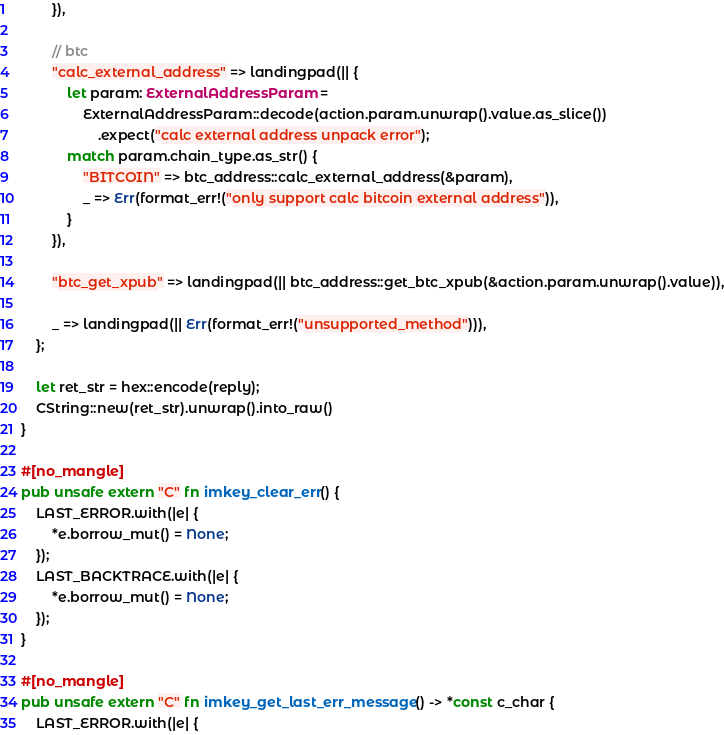Convert code to text. <code><loc_0><loc_0><loc_500><loc_500><_Rust_>        }),

        // btc
        "calc_external_address" => landingpad(|| {
            let param: ExternalAddressParam =
                ExternalAddressParam::decode(action.param.unwrap().value.as_slice())
                    .expect("calc external address unpack error");
            match param.chain_type.as_str() {
                "BITCOIN" => btc_address::calc_external_address(&param),
                _ => Err(format_err!("only support calc bitcoin external address")),
            }
        }),

        "btc_get_xpub" => landingpad(|| btc_address::get_btc_xpub(&action.param.unwrap().value)),

        _ => landingpad(|| Err(format_err!("unsupported_method"))),
    };

    let ret_str = hex::encode(reply);
    CString::new(ret_str).unwrap().into_raw()
}

#[no_mangle]
pub unsafe extern "C" fn imkey_clear_err() {
    LAST_ERROR.with(|e| {
        *e.borrow_mut() = None;
    });
    LAST_BACKTRACE.with(|e| {
        *e.borrow_mut() = None;
    });
}

#[no_mangle]
pub unsafe extern "C" fn imkey_get_last_err_message() -> *const c_char {
    LAST_ERROR.with(|e| {</code> 